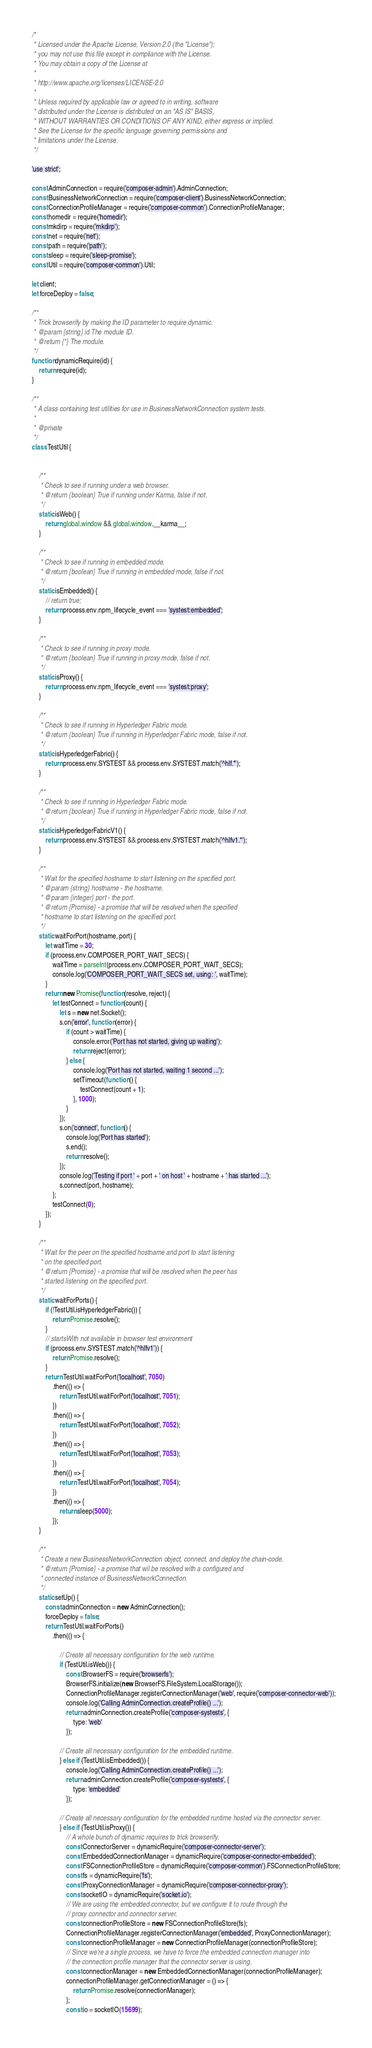<code> <loc_0><loc_0><loc_500><loc_500><_JavaScript_>/*
 * Licensed under the Apache License, Version 2.0 (the "License");
 * you may not use this file except in compliance with the License.
 * You may obtain a copy of the License at
 *
 * http://www.apache.org/licenses/LICENSE-2.0
 *
 * Unless required by applicable law or agreed to in writing, software
 * distributed under the License is distributed on an "AS IS" BASIS,
 * WITHOUT WARRANTIES OR CONDITIONS OF ANY KIND, either express or implied.
 * See the License for the specific language governing permissions and
 * limitations under the License.
 */

'use strict';

const AdminConnection = require('composer-admin').AdminConnection;
const BusinessNetworkConnection = require('composer-client').BusinessNetworkConnection;
const ConnectionProfileManager = require('composer-common').ConnectionProfileManager;
const homedir = require('homedir');
const mkdirp = require('mkdirp');
const net = require('net');
const path = require('path');
const sleep = require('sleep-promise');
const Util = require('composer-common').Util;

let client;
let forceDeploy = false;

/**
 * Trick browserify by making the ID parameter to require dynamic.
 * @param {string} id The module ID.
 * @return {*} The module.
 */
function dynamicRequire(id) {
    return require(id);
}

/**
 * A class containing test utilities for use in BusinessNetworkConnection system tests.
 *
 * @private
 */
class TestUtil {


    /**
     * Check to see if running under a web browser.
     * @return {boolean} True if running under Karma, false if not.
     */
    static isWeb() {
        return global.window && global.window.__karma__;
    }

    /**
     * Check to see if running in embedded mode.
     * @return {boolean} True if running in embedded mode, false if not.
     */
    static isEmbedded() {
        // return true;
        return process.env.npm_lifecycle_event === 'systest:embedded';
    }

    /**
     * Check to see if running in proxy mode.
     * @return {boolean} True if running in proxy mode, false if not.
     */
    static isProxy() {
        return process.env.npm_lifecycle_event === 'systest:proxy';
    }

    /**
     * Check to see if running in Hyperledger Fabric mode.
     * @return {boolean} True if running in Hyperledger Fabric mode, false if not.
     */
    static isHyperledgerFabric() {
        return process.env.SYSTEST && process.env.SYSTEST.match('^hlf.*');
    }

    /**
     * Check to see if running in Hyperledger Fabric mode.
     * @return {boolean} True if running in Hyperledger Fabric mode, false if not.
     */
    static isHyperledgerFabricV1() {
        return process.env.SYSTEST && process.env.SYSTEST.match('^hlfv1.*');
    }

    /**
     * Wait for the specified hostname to start listening on the specified port.
     * @param {string} hostname - the hostname.
     * @param {integer} port - the port.
     * @return {Promise} - a promise that will be resolved when the specified
     * hostname to start listening on the specified port.
     */
    static waitForPort(hostname, port) {
        let waitTime = 30;
        if (process.env.COMPOSER_PORT_WAIT_SECS) {
            waitTime = parseInt(process.env.COMPOSER_PORT_WAIT_SECS);
            console.log('COMPOSER_PORT_WAIT_SECS set, using: ', waitTime);
        }
        return new Promise(function (resolve, reject) {
            let testConnect = function (count) {
                let s = new net.Socket();
                s.on('error', function (error) {
                    if (count > waitTime) {
                        console.error('Port has not started, giving up waiting');
                        return reject(error);
                    } else {
                        console.log('Port has not started, waiting 1 second ...');
                        setTimeout(function () {
                            testConnect(count + 1);
                        }, 1000);
                    }
                });
                s.on('connect', function () {
                    console.log('Port has started');
                    s.end();
                    return resolve();
                });
                console.log('Testing if port ' + port + ' on host ' + hostname + ' has started ...');
                s.connect(port, hostname);
            };
            testConnect(0);
        });
    }

    /**
     * Wait for the peer on the specified hostname and port to start listening
     * on the specified port.
     * @return {Promise} - a promise that will be resolved when the peer has
     * started listening on the specified port.
     */
    static waitForPorts() {
        if (!TestUtil.isHyperledgerFabric()) {
            return Promise.resolve();
        }
        // startsWith not available in browser test environment
        if (process.env.SYSTEST.match('^hlfv1')) {
            return Promise.resolve();
        }
        return TestUtil.waitForPort('localhost', 7050)
            .then(() => {
                return TestUtil.waitForPort('localhost', 7051);
            })
            .then(() => {
                return TestUtil.waitForPort('localhost', 7052);
            })
            .then(() => {
                return TestUtil.waitForPort('localhost', 7053);
            })
            .then(() => {
                return TestUtil.waitForPort('localhost', 7054);
            })
            .then(() => {
                return sleep(5000);
            });
    }

    /**
     * Create a new BusinessNetworkConnection object, connect, and deploy the chain-code.
     * @return {Promise} - a promise that wil be resolved with a configured and
     * connected instance of BusinessNetworkConnection.
     */
    static setUp() {
        const adminConnection = new AdminConnection();
        forceDeploy = false;
        return TestUtil.waitForPorts()
            .then(() => {

                // Create all necessary configuration for the web runtime.
                if (TestUtil.isWeb()) {
                    const BrowserFS = require('browserfs');
                    BrowserFS.initialize(new BrowserFS.FileSystem.LocalStorage());
                    ConnectionProfileManager.registerConnectionManager('web', require('composer-connector-web'));
                    console.log('Calling AdminConnection.createProfile() ...');
                    return adminConnection.createProfile('composer-systests', {
                        type: 'web'
                    });

                // Create all necessary configuration for the embedded runtime.
                } else if (TestUtil.isEmbedded()) {
                    console.log('Calling AdminConnection.createProfile() ...');
                    return adminConnection.createProfile('composer-systests', {
                        type: 'embedded'
                    });

                // Create all necessary configuration for the embedded runtime hosted via the connector server.
                } else if (TestUtil.isProxy()) {
                    // A whole bunch of dynamic requires to trick browserify.
                    const ConnectorServer = dynamicRequire('composer-connector-server');
                    const EmbeddedConnectionManager = dynamicRequire('composer-connector-embedded');
                    const FSConnectionProfileStore = dynamicRequire('composer-common').FSConnectionProfileStore;
                    const fs = dynamicRequire('fs');
                    const ProxyConnectionManager = dynamicRequire('composer-connector-proxy');
                    const socketIO = dynamicRequire('socket.io');
                    // We are using the embedded connector, but we configure it to route through the
                    // proxy connector and connector server.
                    const connectionProfileStore = new FSConnectionProfileStore(fs);
                    ConnectionProfileManager.registerConnectionManager('embedded', ProxyConnectionManager);
                    const connectionProfileManager = new ConnectionProfileManager(connectionProfileStore);
                    // Since we're a single process, we have to force the embedded connection manager into
                    // the connection profile manager that the connector server is using.
                    const connectionManager = new EmbeddedConnectionManager(connectionProfileManager);
                    connectionProfileManager.getConnectionManager = () => {
                        return Promise.resolve(connectionManager);
                    };
                    const io = socketIO(15699);</code> 